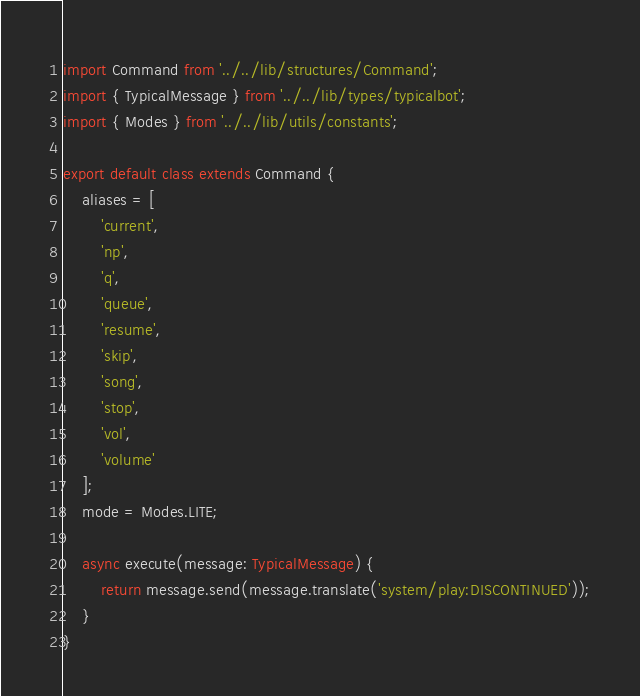Convert code to text. <code><loc_0><loc_0><loc_500><loc_500><_TypeScript_>import Command from '../../lib/structures/Command';
import { TypicalMessage } from '../../lib/types/typicalbot';
import { Modes } from '../../lib/utils/constants';

export default class extends Command {
    aliases = [
        'current',
        'np',
        'q',
        'queue',
        'resume',
        'skip',
        'song',
        'stop',
        'vol',
        'volume'
    ];
    mode = Modes.LITE;

    async execute(message: TypicalMessage) {
        return message.send(message.translate('system/play:DISCONTINUED'));
    }
}
</code> 